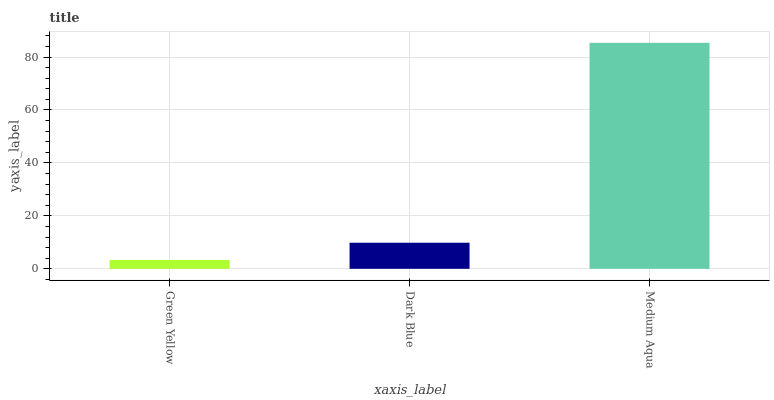Is Green Yellow the minimum?
Answer yes or no. Yes. Is Medium Aqua the maximum?
Answer yes or no. Yes. Is Dark Blue the minimum?
Answer yes or no. No. Is Dark Blue the maximum?
Answer yes or no. No. Is Dark Blue greater than Green Yellow?
Answer yes or no. Yes. Is Green Yellow less than Dark Blue?
Answer yes or no. Yes. Is Green Yellow greater than Dark Blue?
Answer yes or no. No. Is Dark Blue less than Green Yellow?
Answer yes or no. No. Is Dark Blue the high median?
Answer yes or no. Yes. Is Dark Blue the low median?
Answer yes or no. Yes. Is Medium Aqua the high median?
Answer yes or no. No. Is Medium Aqua the low median?
Answer yes or no. No. 